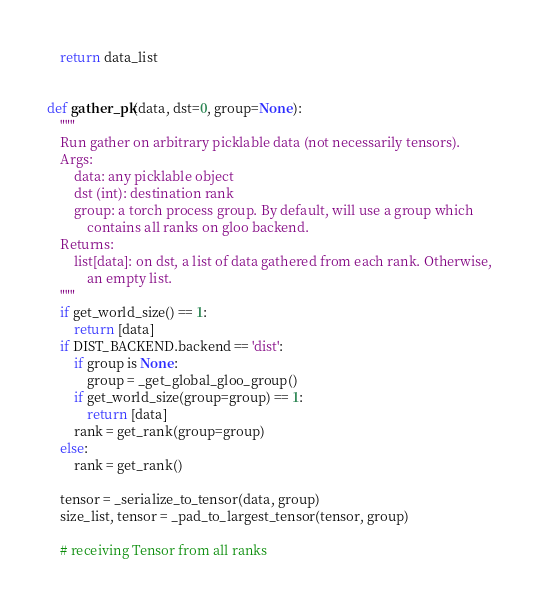<code> <loc_0><loc_0><loc_500><loc_500><_Python_>
    return data_list


def gather_pk(data, dst=0, group=None):
    """
    Run gather on arbitrary picklable data (not necessarily tensors).
    Args:
        data: any picklable object
        dst (int): destination rank
        group: a torch process group. By default, will use a group which
            contains all ranks on gloo backend.
    Returns:
        list[data]: on dst, a list of data gathered from each rank. Otherwise,
            an empty list.
    """
    if get_world_size() == 1:
        return [data]
    if DIST_BACKEND.backend == 'dist':
        if group is None:
            group = _get_global_gloo_group()
        if get_world_size(group=group) == 1:
            return [data]
        rank = get_rank(group=group)
    else:
        rank = get_rank()

    tensor = _serialize_to_tensor(data, group)
    size_list, tensor = _pad_to_largest_tensor(tensor, group)

    # receiving Tensor from all ranks</code> 